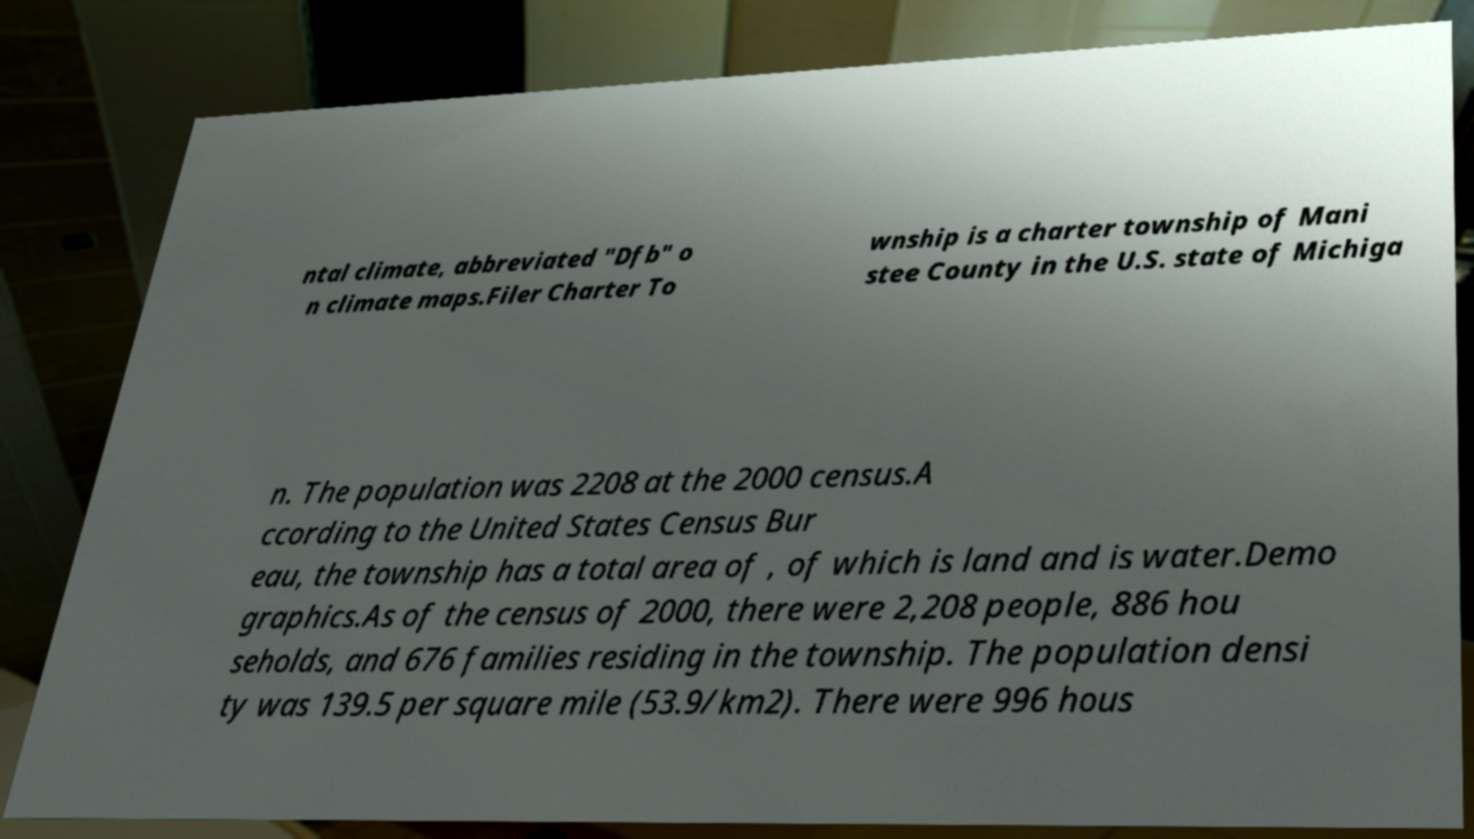Could you assist in decoding the text presented in this image and type it out clearly? ntal climate, abbreviated "Dfb" o n climate maps.Filer Charter To wnship is a charter township of Mani stee County in the U.S. state of Michiga n. The population was 2208 at the 2000 census.A ccording to the United States Census Bur eau, the township has a total area of , of which is land and is water.Demo graphics.As of the census of 2000, there were 2,208 people, 886 hou seholds, and 676 families residing in the township. The population densi ty was 139.5 per square mile (53.9/km2). There were 996 hous 